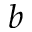Convert formula to latex. <formula><loc_0><loc_0><loc_500><loc_500>b</formula> 